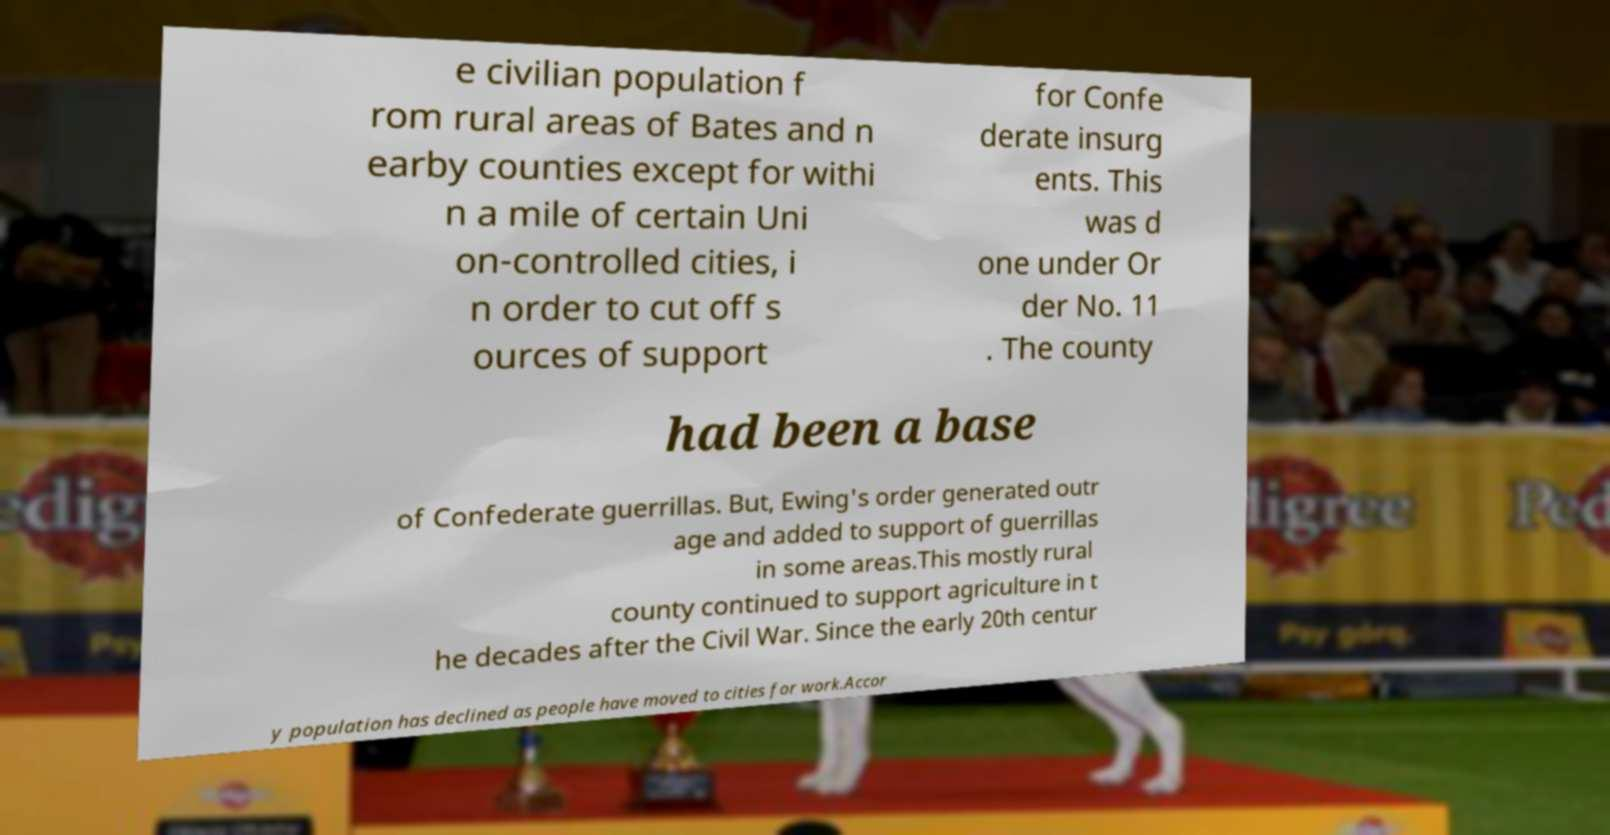Please identify and transcribe the text found in this image. e civilian population f rom rural areas of Bates and n earby counties except for withi n a mile of certain Uni on-controlled cities, i n order to cut off s ources of support for Confe derate insurg ents. This was d one under Or der No. 11 . The county had been a base of Confederate guerrillas. But, Ewing's order generated outr age and added to support of guerrillas in some areas.This mostly rural county continued to support agriculture in t he decades after the Civil War. Since the early 20th centur y population has declined as people have moved to cities for work.Accor 